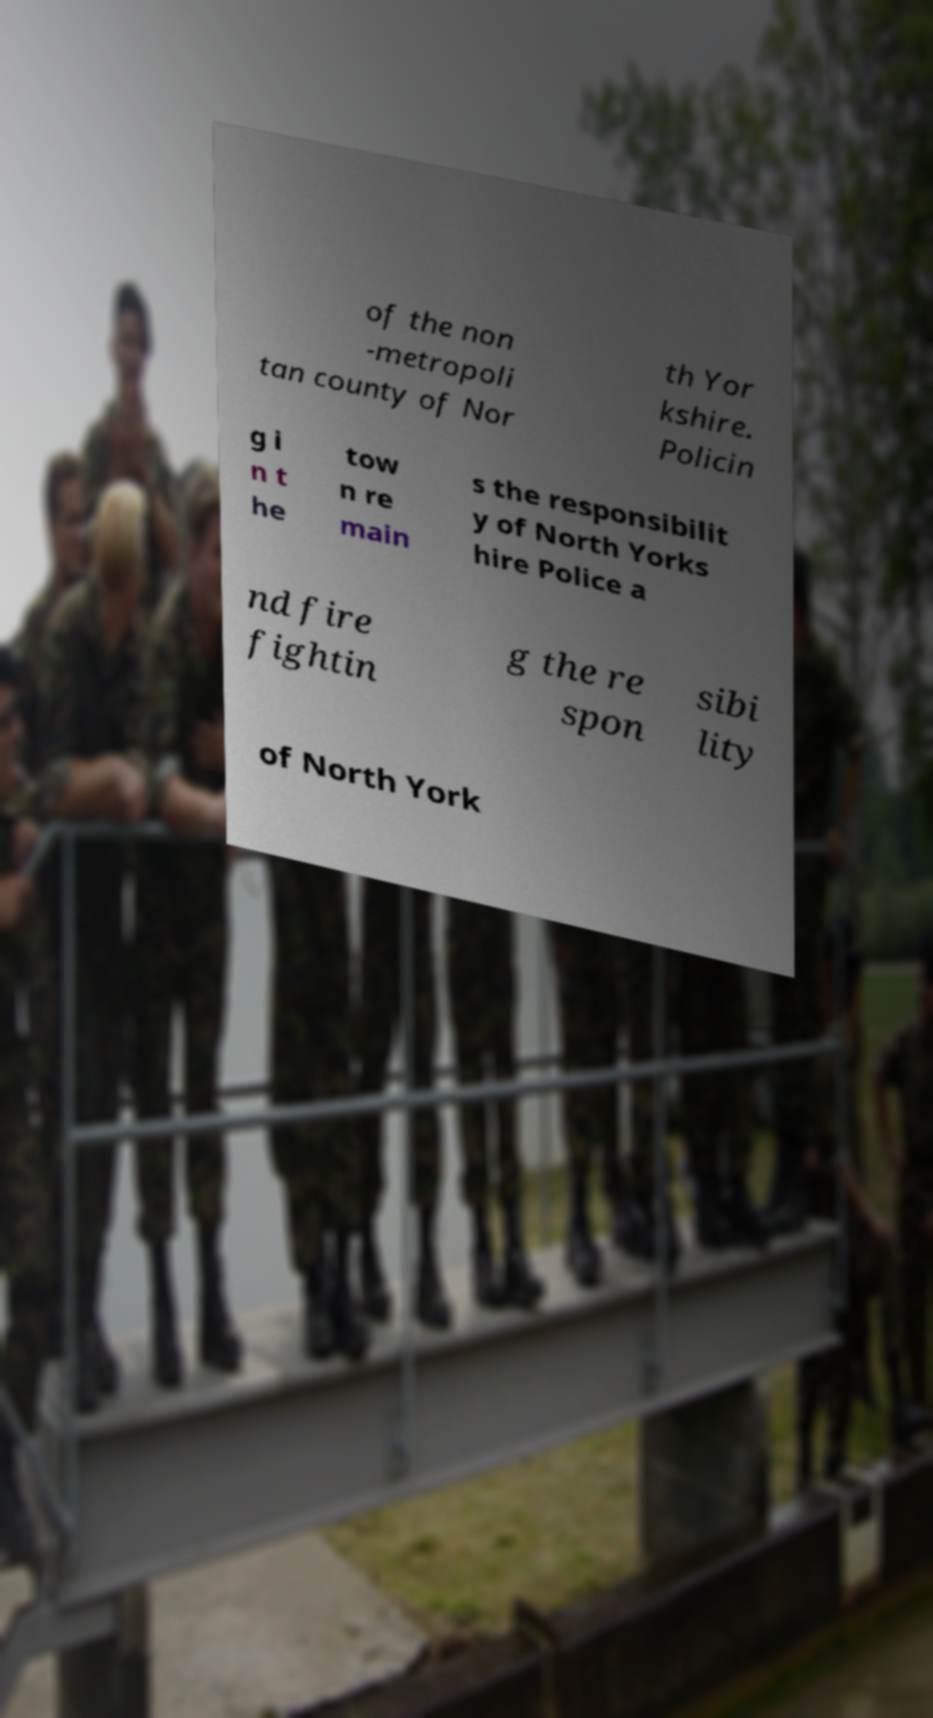There's text embedded in this image that I need extracted. Can you transcribe it verbatim? of the non -metropoli tan county of Nor th Yor kshire. Policin g i n t he tow n re main s the responsibilit y of North Yorks hire Police a nd fire fightin g the re spon sibi lity of North York 